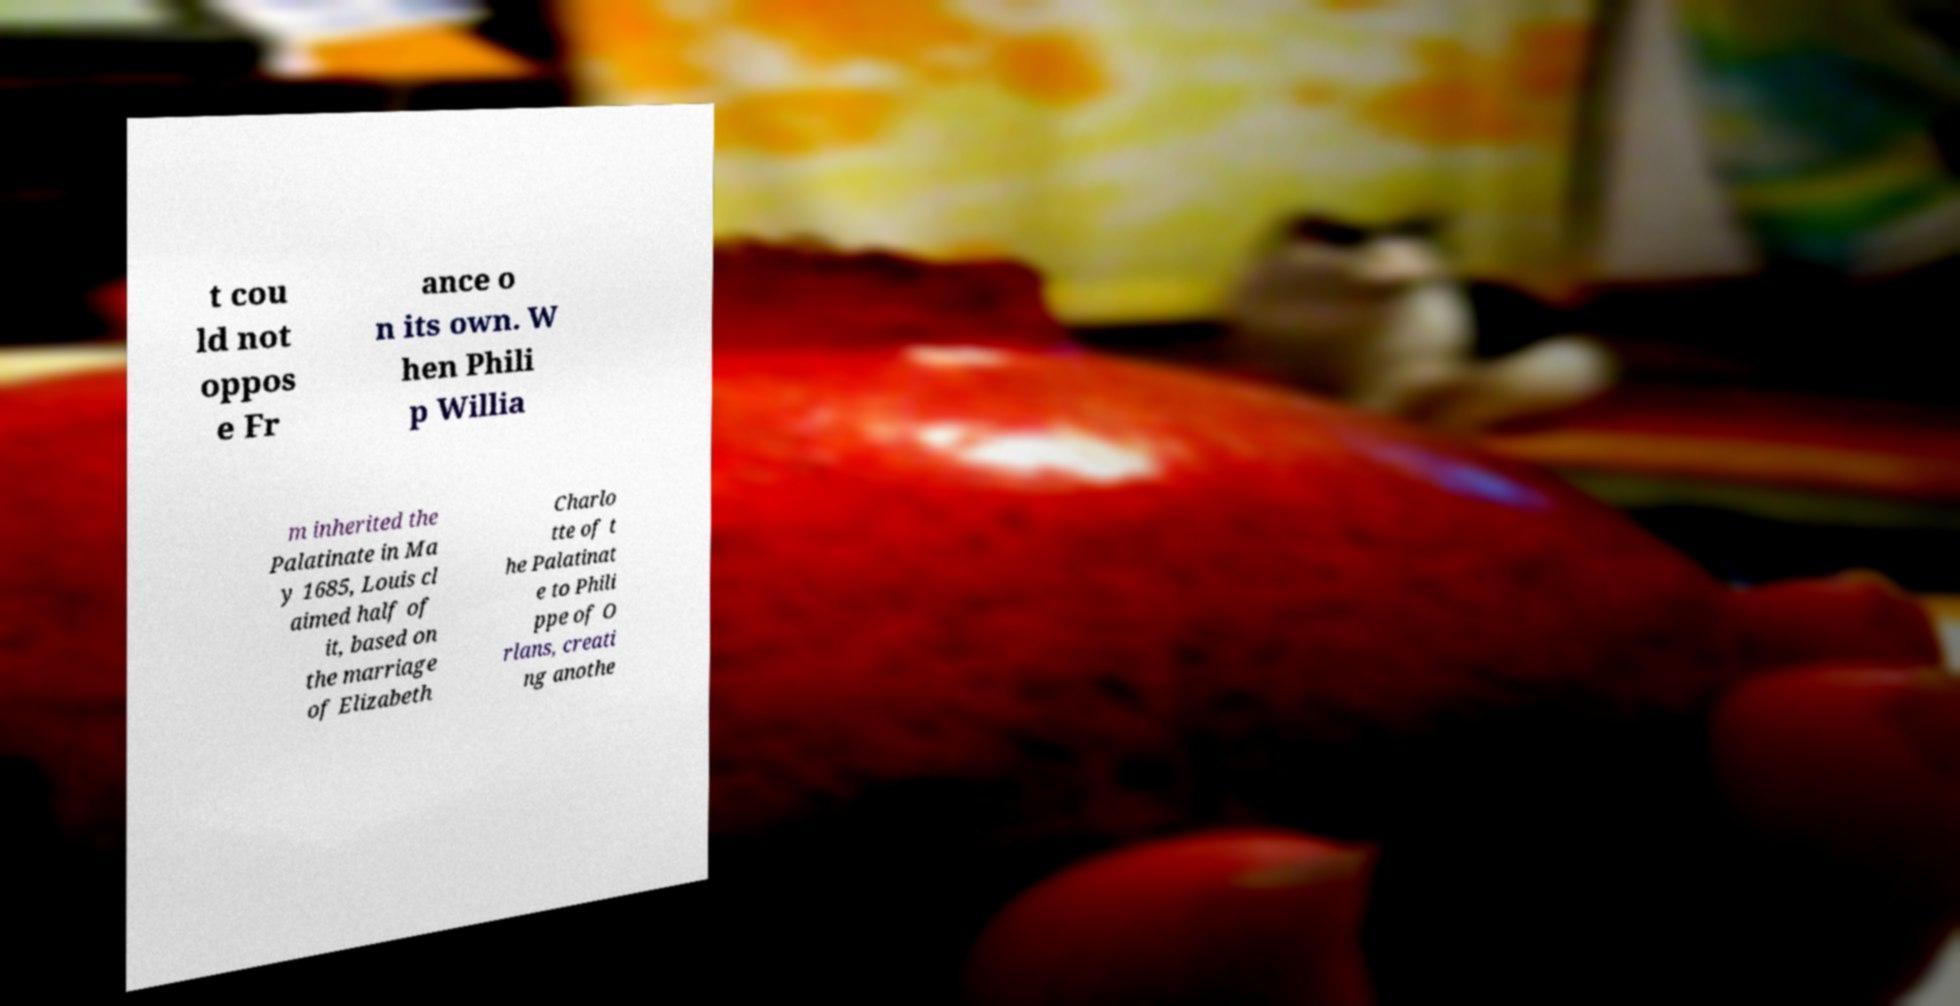Please read and relay the text visible in this image. What does it say? t cou ld not oppos e Fr ance o n its own. W hen Phili p Willia m inherited the Palatinate in Ma y 1685, Louis cl aimed half of it, based on the marriage of Elizabeth Charlo tte of t he Palatinat e to Phili ppe of O rlans, creati ng anothe 